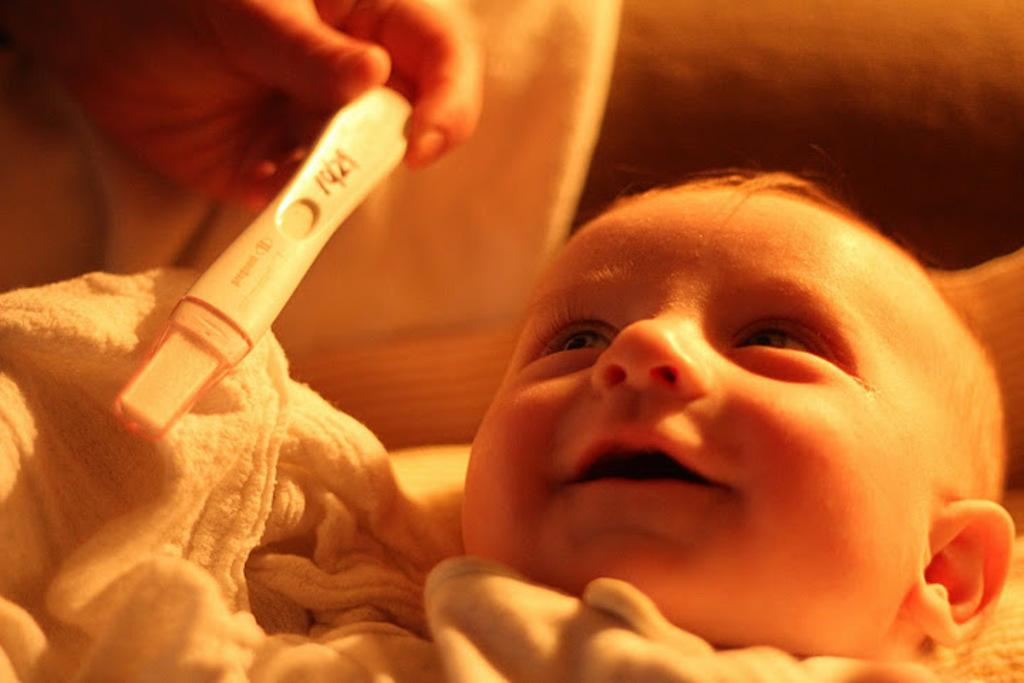What is the main subject of the image? There is a small baby in the image. What can be seen in the foreground of the image? There is a towel in the foreground. Can you describe the object in someone's hand in the top left side of the image? Unfortunately, the facts provided do not give enough information to describe the object in someone's hand. What news headline is visible on the calculator in the image? There is no calculator or news headline present in the image. 